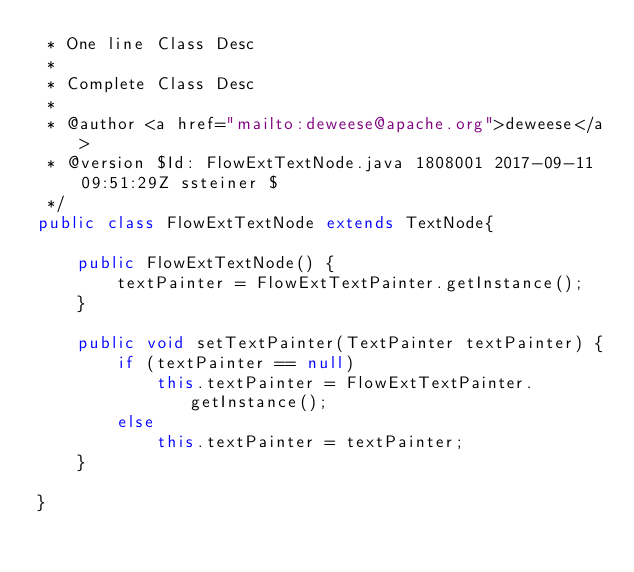Convert code to text. <code><loc_0><loc_0><loc_500><loc_500><_Java_> * One line Class Desc
 *
 * Complete Class Desc
 *
 * @author <a href="mailto:deweese@apache.org">deweese</a>
 * @version $Id: FlowExtTextNode.java 1808001 2017-09-11 09:51:29Z ssteiner $
 */
public class FlowExtTextNode extends TextNode{

    public FlowExtTextNode() {
        textPainter = FlowExtTextPainter.getInstance();
    }

    public void setTextPainter(TextPainter textPainter) {
        if (textPainter == null)
            this.textPainter = FlowExtTextPainter.getInstance();
        else
            this.textPainter = textPainter;
    }

}
</code> 